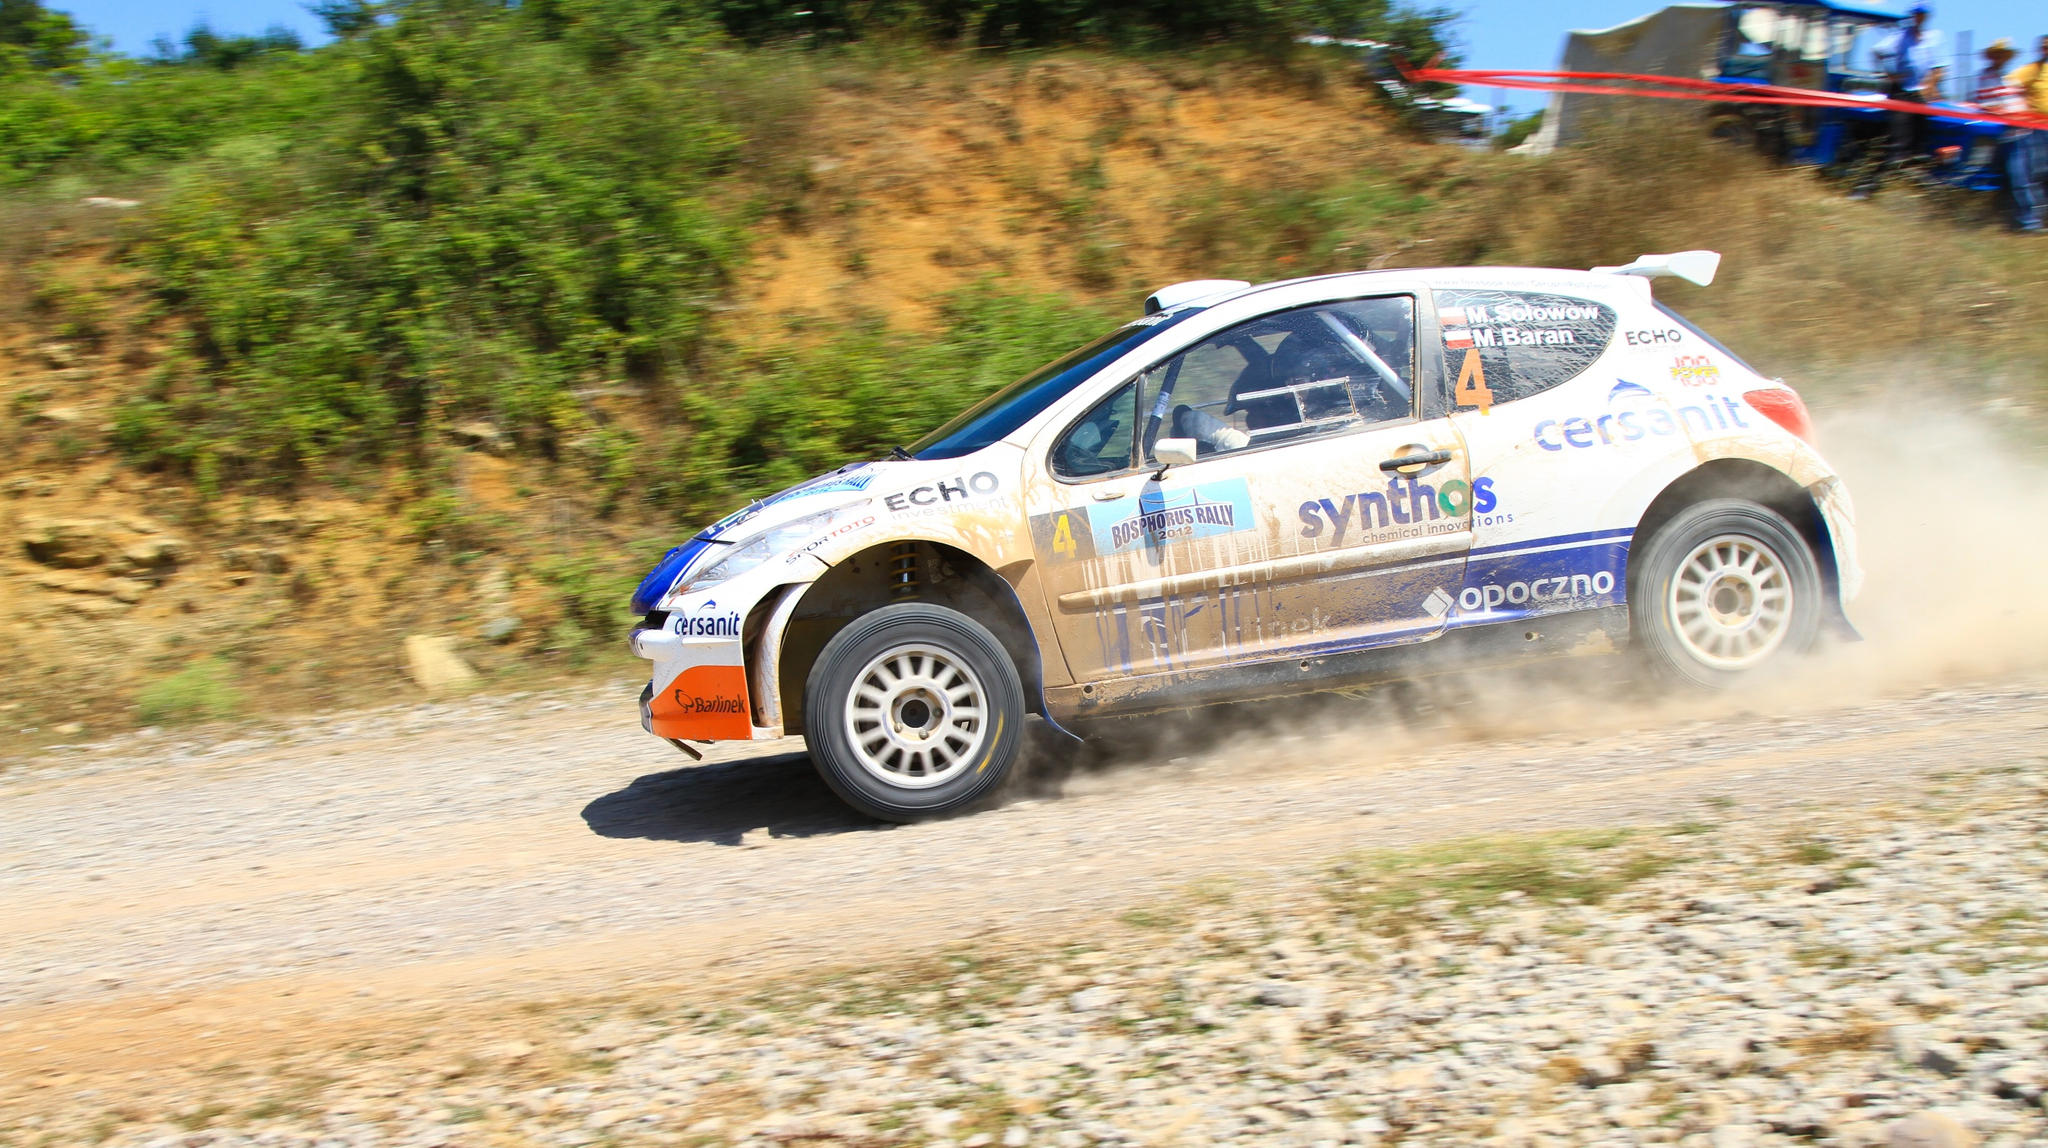What do you think is going on in this snapshot? The image vividly captures a moment during a rally car competition. A white hatchback, dynamically adorned with blue and orange decals labeled 'synthos', 'cersanit', and 'opoczno', zooms across a dirt track. You can see how the car kicks up a thick cloud of dust in its wake, highlighting the high-speed action. The car is not only moving quickly but also appears to be in the midst of a maneuver, as evidenced by its angled trajectory towards the right side of the frame. A spoiler adds to the aerodynamic design that is typical for such high-performance sports vehicles. The backdrop features a lush green hill and scattered trees under a clear blue sky, adding a serene contrast to the car’s aggressive motion. This setting provides a perfect arena for such thrilling motorsport events. 